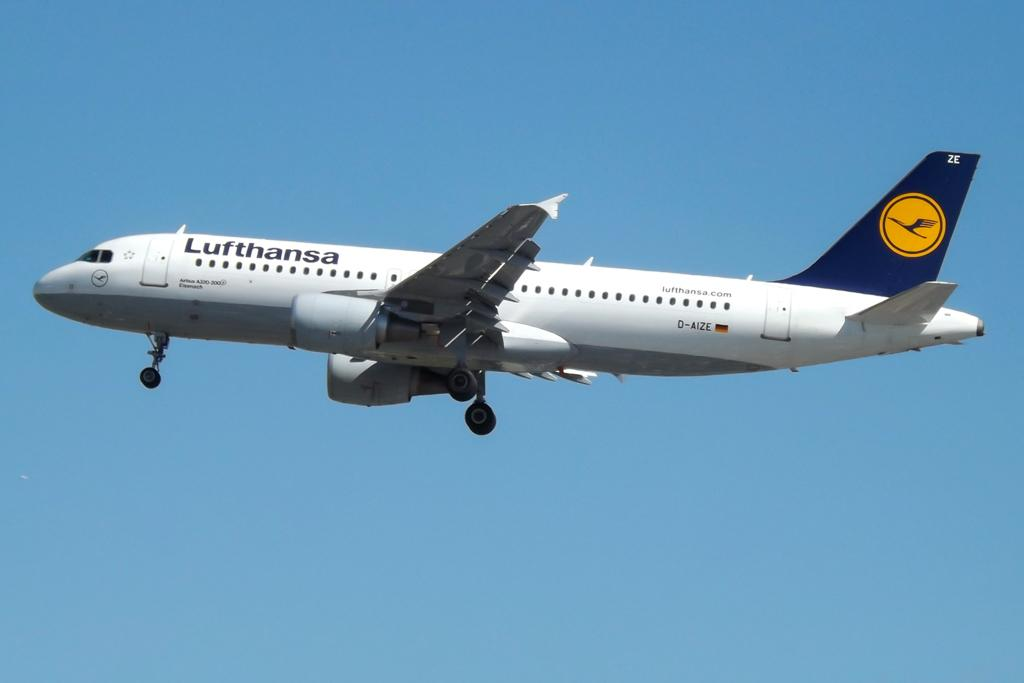<image>
Provide a brief description of the given image. A large Lufthansa plane is flying through a clear blue sky 